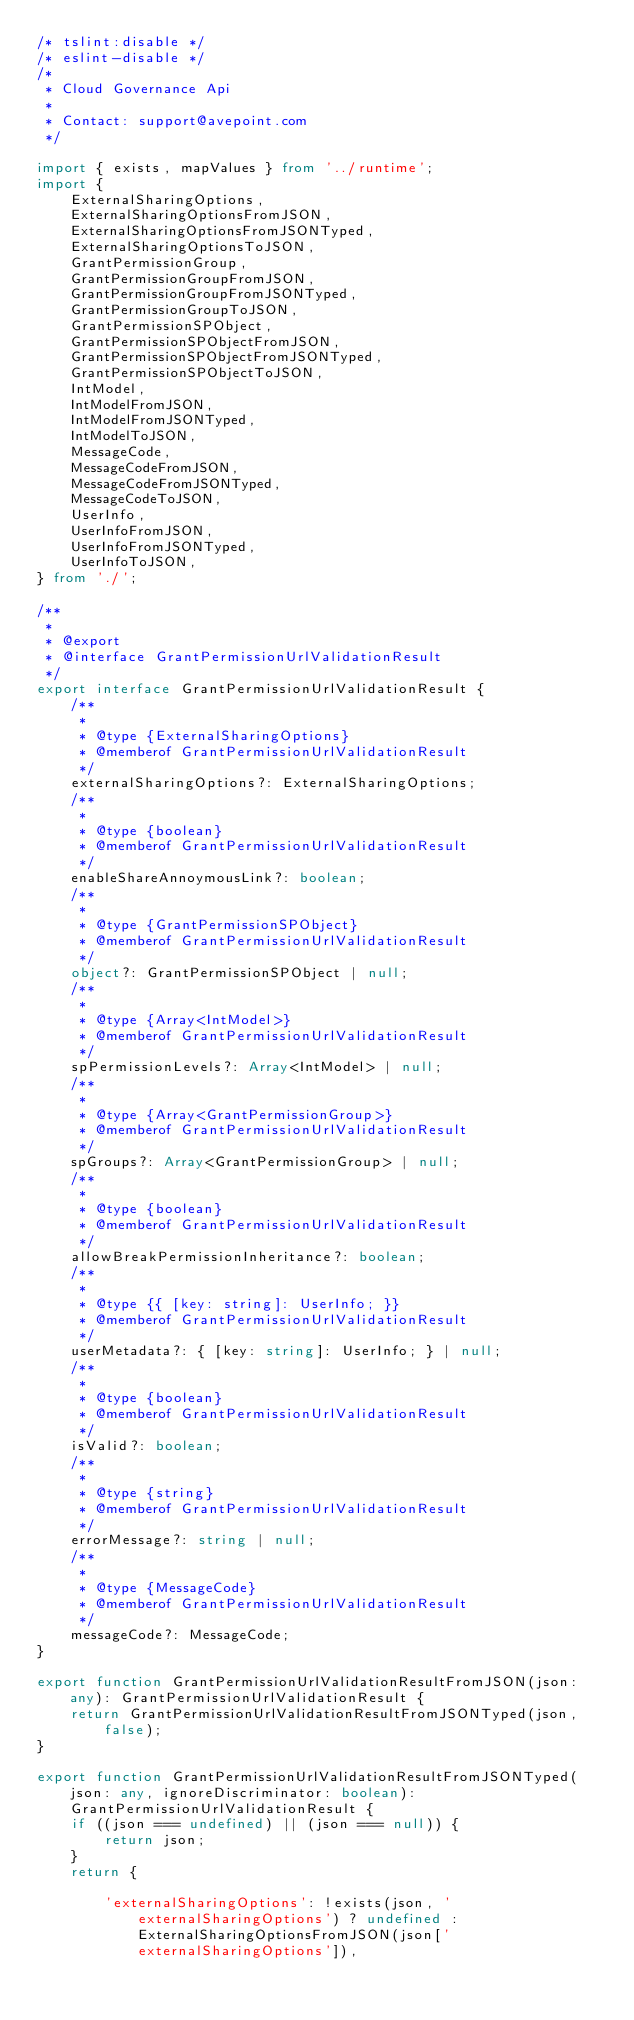<code> <loc_0><loc_0><loc_500><loc_500><_TypeScript_>/* tslint:disable */
/* eslint-disable */
/*
 * Cloud Governance Api
 *
 * Contact: support@avepoint.com
 */

import { exists, mapValues } from '../runtime';
import {
    ExternalSharingOptions,
    ExternalSharingOptionsFromJSON,
    ExternalSharingOptionsFromJSONTyped,
    ExternalSharingOptionsToJSON,
    GrantPermissionGroup,
    GrantPermissionGroupFromJSON,
    GrantPermissionGroupFromJSONTyped,
    GrantPermissionGroupToJSON,
    GrantPermissionSPObject,
    GrantPermissionSPObjectFromJSON,
    GrantPermissionSPObjectFromJSONTyped,
    GrantPermissionSPObjectToJSON,
    IntModel,
    IntModelFromJSON,
    IntModelFromJSONTyped,
    IntModelToJSON,
    MessageCode,
    MessageCodeFromJSON,
    MessageCodeFromJSONTyped,
    MessageCodeToJSON,
    UserInfo,
    UserInfoFromJSON,
    UserInfoFromJSONTyped,
    UserInfoToJSON,
} from './';

/**
 * 
 * @export
 * @interface GrantPermissionUrlValidationResult
 */
export interface GrantPermissionUrlValidationResult {
    /**
     * 
     * @type {ExternalSharingOptions}
     * @memberof GrantPermissionUrlValidationResult
     */
    externalSharingOptions?: ExternalSharingOptions;
    /**
     * 
     * @type {boolean}
     * @memberof GrantPermissionUrlValidationResult
     */
    enableShareAnnoymousLink?: boolean;
    /**
     * 
     * @type {GrantPermissionSPObject}
     * @memberof GrantPermissionUrlValidationResult
     */
    object?: GrantPermissionSPObject | null;
    /**
     * 
     * @type {Array<IntModel>}
     * @memberof GrantPermissionUrlValidationResult
     */
    spPermissionLevels?: Array<IntModel> | null;
    /**
     * 
     * @type {Array<GrantPermissionGroup>}
     * @memberof GrantPermissionUrlValidationResult
     */
    spGroups?: Array<GrantPermissionGroup> | null;
    /**
     * 
     * @type {boolean}
     * @memberof GrantPermissionUrlValidationResult
     */
    allowBreakPermissionInheritance?: boolean;
    /**
     * 
     * @type {{ [key: string]: UserInfo; }}
     * @memberof GrantPermissionUrlValidationResult
     */
    userMetadata?: { [key: string]: UserInfo; } | null;
    /**
     * 
     * @type {boolean}
     * @memberof GrantPermissionUrlValidationResult
     */
    isValid?: boolean;
    /**
     * 
     * @type {string}
     * @memberof GrantPermissionUrlValidationResult
     */
    errorMessage?: string | null;
    /**
     * 
     * @type {MessageCode}
     * @memberof GrantPermissionUrlValidationResult
     */
    messageCode?: MessageCode;
}

export function GrantPermissionUrlValidationResultFromJSON(json: any): GrantPermissionUrlValidationResult {
    return GrantPermissionUrlValidationResultFromJSONTyped(json, false);
}

export function GrantPermissionUrlValidationResultFromJSONTyped(json: any, ignoreDiscriminator: boolean): GrantPermissionUrlValidationResult {
    if ((json === undefined) || (json === null)) {
        return json;
    }
    return {
        
        'externalSharingOptions': !exists(json, 'externalSharingOptions') ? undefined : ExternalSharingOptionsFromJSON(json['externalSharingOptions']),</code> 